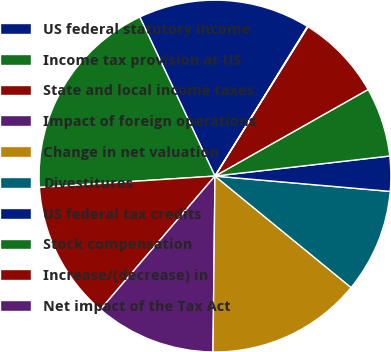Convert chart to OTSL. <chart><loc_0><loc_0><loc_500><loc_500><pie_chart><fcel>US federal statutory income<fcel>Income tax provision at US<fcel>State and local income taxes<fcel>Impact of foreign operations<fcel>Change in net valuation<fcel>Divestitures<fcel>US federal tax credits<fcel>Stock compensation<fcel>Increase/(decrease) in<fcel>Net impact of the Tax Act<nl><fcel>15.84%<fcel>19.0%<fcel>12.68%<fcel>11.11%<fcel>14.26%<fcel>9.53%<fcel>3.21%<fcel>6.37%<fcel>7.95%<fcel>0.05%<nl></chart> 